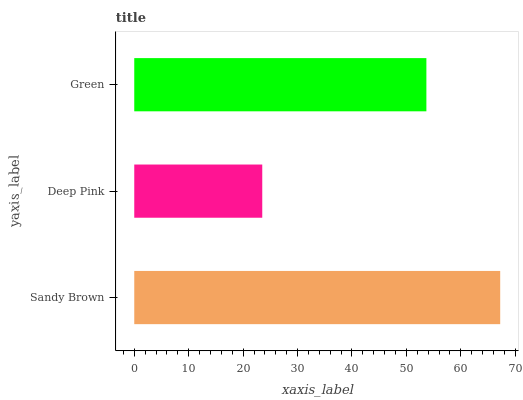Is Deep Pink the minimum?
Answer yes or no. Yes. Is Sandy Brown the maximum?
Answer yes or no. Yes. Is Green the minimum?
Answer yes or no. No. Is Green the maximum?
Answer yes or no. No. Is Green greater than Deep Pink?
Answer yes or no. Yes. Is Deep Pink less than Green?
Answer yes or no. Yes. Is Deep Pink greater than Green?
Answer yes or no. No. Is Green less than Deep Pink?
Answer yes or no. No. Is Green the high median?
Answer yes or no. Yes. Is Green the low median?
Answer yes or no. Yes. Is Deep Pink the high median?
Answer yes or no. No. Is Deep Pink the low median?
Answer yes or no. No. 